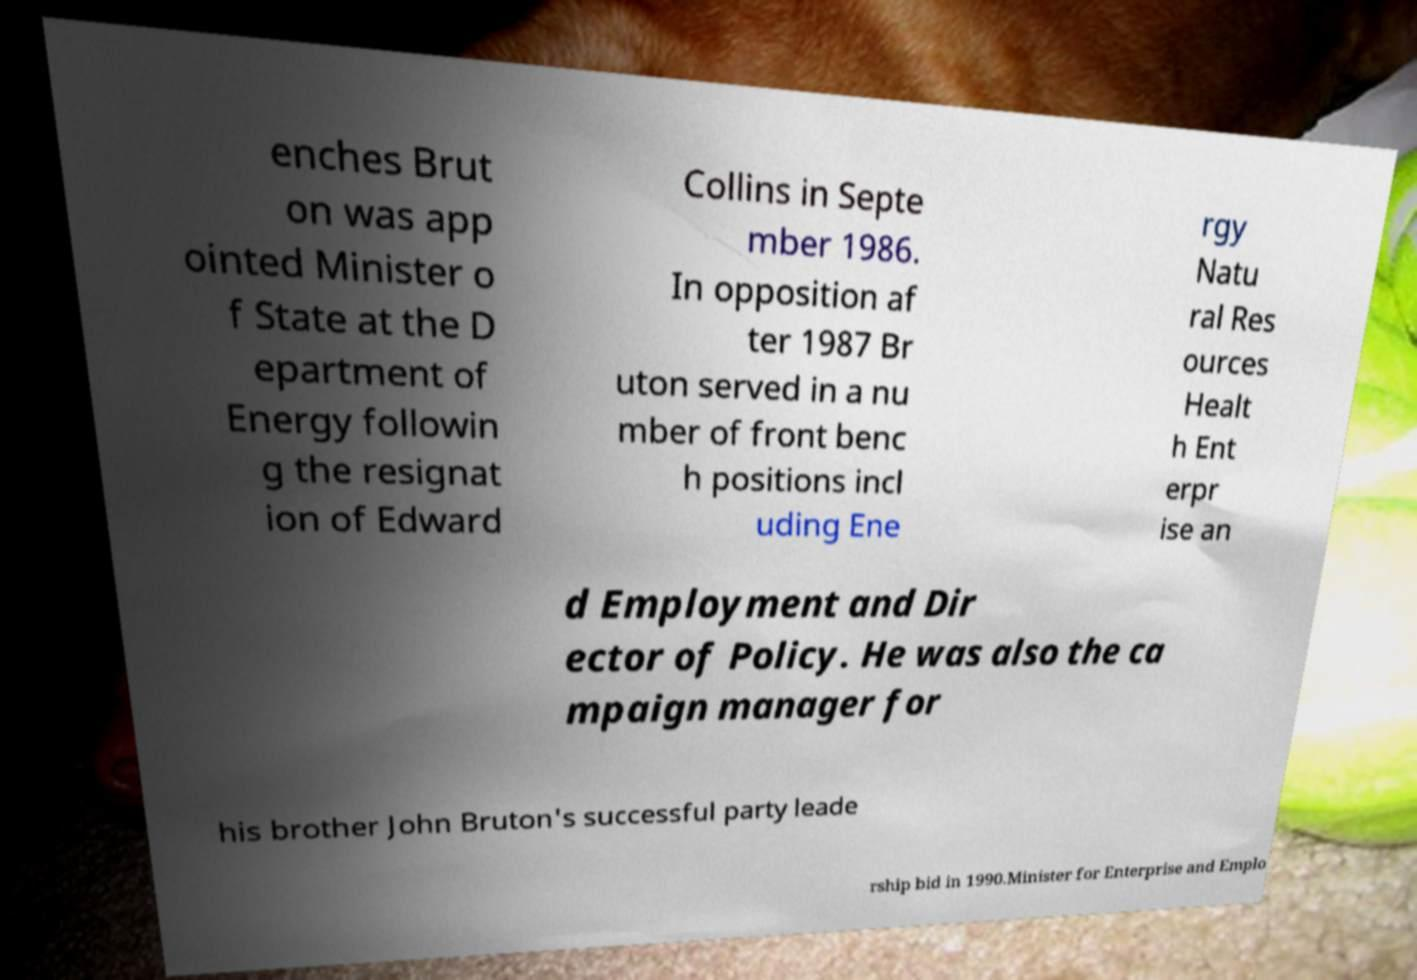There's text embedded in this image that I need extracted. Can you transcribe it verbatim? enches Brut on was app ointed Minister o f State at the D epartment of Energy followin g the resignat ion of Edward Collins in Septe mber 1986. In opposition af ter 1987 Br uton served in a nu mber of front benc h positions incl uding Ene rgy Natu ral Res ources Healt h Ent erpr ise an d Employment and Dir ector of Policy. He was also the ca mpaign manager for his brother John Bruton's successful party leade rship bid in 1990.Minister for Enterprise and Emplo 